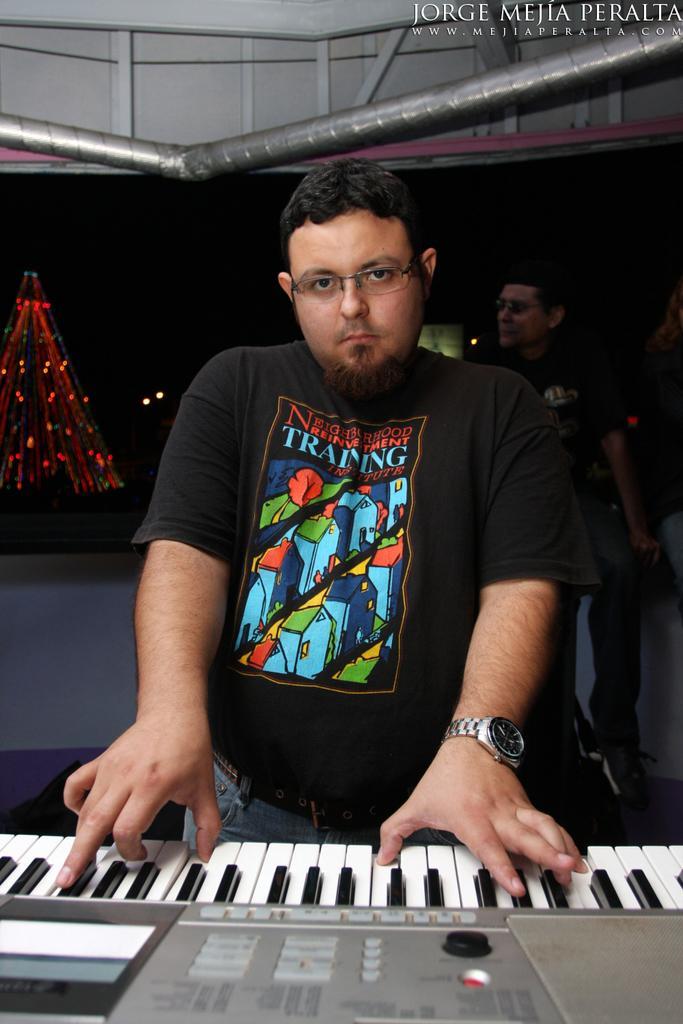Describe this image in one or two sentences. In this picture we can see a man who is playing piano. He wear a watch and he has spectacles. On the background we can see a one more person standing on the floor. And these are the lights. 